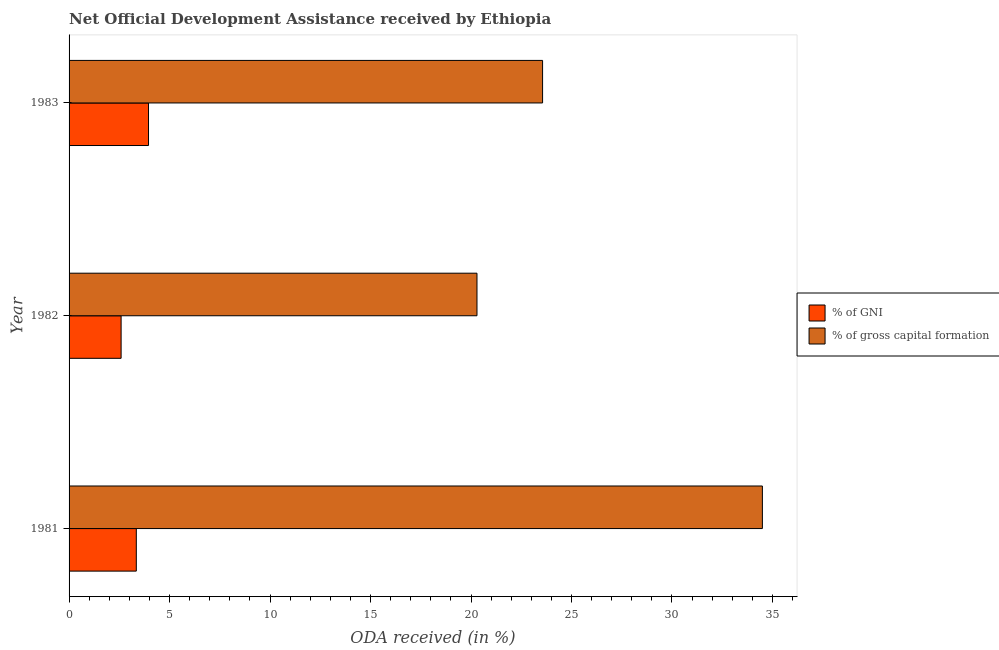How many different coloured bars are there?
Make the answer very short. 2. Are the number of bars per tick equal to the number of legend labels?
Provide a succinct answer. Yes. Are the number of bars on each tick of the Y-axis equal?
Offer a very short reply. Yes. How many bars are there on the 2nd tick from the bottom?
Offer a terse response. 2. In how many cases, is the number of bars for a given year not equal to the number of legend labels?
Make the answer very short. 0. What is the oda received as percentage of gni in 1981?
Offer a terse response. 3.35. Across all years, what is the maximum oda received as percentage of gross capital formation?
Give a very brief answer. 34.5. Across all years, what is the minimum oda received as percentage of gni?
Offer a very short reply. 2.59. In which year was the oda received as percentage of gross capital formation minimum?
Make the answer very short. 1982. What is the total oda received as percentage of gross capital formation in the graph?
Make the answer very short. 78.36. What is the difference between the oda received as percentage of gross capital formation in 1981 and that in 1983?
Your answer should be compact. 10.94. What is the difference between the oda received as percentage of gross capital formation in 1982 and the oda received as percentage of gni in 1983?
Keep it short and to the point. 16.34. What is the average oda received as percentage of gni per year?
Ensure brevity in your answer.  3.3. In the year 1981, what is the difference between the oda received as percentage of gross capital formation and oda received as percentage of gni?
Keep it short and to the point. 31.15. In how many years, is the oda received as percentage of gross capital formation greater than 7 %?
Your answer should be very brief. 3. What is the ratio of the oda received as percentage of gross capital formation in 1981 to that in 1983?
Provide a succinct answer. 1.46. Is the oda received as percentage of gross capital formation in 1982 less than that in 1983?
Provide a short and direct response. Yes. What is the difference between the highest and the second highest oda received as percentage of gross capital formation?
Your answer should be compact. 10.94. What is the difference between the highest and the lowest oda received as percentage of gross capital formation?
Your answer should be very brief. 14.2. In how many years, is the oda received as percentage of gross capital formation greater than the average oda received as percentage of gross capital formation taken over all years?
Give a very brief answer. 1. What does the 1st bar from the top in 1982 represents?
Provide a succinct answer. % of gross capital formation. What does the 2nd bar from the bottom in 1982 represents?
Offer a very short reply. % of gross capital formation. How many bars are there?
Offer a terse response. 6. Are all the bars in the graph horizontal?
Offer a terse response. Yes. Does the graph contain any zero values?
Your response must be concise. No. Where does the legend appear in the graph?
Keep it short and to the point. Center right. How many legend labels are there?
Your answer should be very brief. 2. What is the title of the graph?
Provide a succinct answer. Net Official Development Assistance received by Ethiopia. Does "Stunting" appear as one of the legend labels in the graph?
Give a very brief answer. No. What is the label or title of the X-axis?
Offer a very short reply. ODA received (in %). What is the label or title of the Y-axis?
Ensure brevity in your answer.  Year. What is the ODA received (in %) in % of GNI in 1981?
Offer a very short reply. 3.35. What is the ODA received (in %) of % of gross capital formation in 1981?
Make the answer very short. 34.5. What is the ODA received (in %) of % of GNI in 1982?
Your answer should be very brief. 2.59. What is the ODA received (in %) of % of gross capital formation in 1982?
Offer a very short reply. 20.3. What is the ODA received (in %) of % of GNI in 1983?
Your response must be concise. 3.95. What is the ODA received (in %) of % of gross capital formation in 1983?
Provide a succinct answer. 23.56. Across all years, what is the maximum ODA received (in %) in % of GNI?
Your answer should be compact. 3.95. Across all years, what is the maximum ODA received (in %) of % of gross capital formation?
Provide a succinct answer. 34.5. Across all years, what is the minimum ODA received (in %) of % of GNI?
Your answer should be very brief. 2.59. Across all years, what is the minimum ODA received (in %) in % of gross capital formation?
Your answer should be compact. 20.3. What is the total ODA received (in %) in % of GNI in the graph?
Your answer should be compact. 9.89. What is the total ODA received (in %) of % of gross capital formation in the graph?
Provide a succinct answer. 78.36. What is the difference between the ODA received (in %) in % of GNI in 1981 and that in 1982?
Your answer should be very brief. 0.76. What is the difference between the ODA received (in %) of % of gross capital formation in 1981 and that in 1982?
Offer a terse response. 14.2. What is the difference between the ODA received (in %) in % of GNI in 1981 and that in 1983?
Offer a very short reply. -0.61. What is the difference between the ODA received (in %) of % of gross capital formation in 1981 and that in 1983?
Your answer should be compact. 10.94. What is the difference between the ODA received (in %) in % of GNI in 1982 and that in 1983?
Your response must be concise. -1.36. What is the difference between the ODA received (in %) of % of gross capital formation in 1982 and that in 1983?
Your answer should be compact. -3.26. What is the difference between the ODA received (in %) in % of GNI in 1981 and the ODA received (in %) in % of gross capital formation in 1982?
Provide a succinct answer. -16.95. What is the difference between the ODA received (in %) of % of GNI in 1981 and the ODA received (in %) of % of gross capital formation in 1983?
Ensure brevity in your answer.  -20.22. What is the difference between the ODA received (in %) in % of GNI in 1982 and the ODA received (in %) in % of gross capital formation in 1983?
Your response must be concise. -20.97. What is the average ODA received (in %) in % of GNI per year?
Your answer should be very brief. 3.3. What is the average ODA received (in %) of % of gross capital formation per year?
Your answer should be very brief. 26.12. In the year 1981, what is the difference between the ODA received (in %) in % of GNI and ODA received (in %) in % of gross capital formation?
Provide a succinct answer. -31.15. In the year 1982, what is the difference between the ODA received (in %) of % of GNI and ODA received (in %) of % of gross capital formation?
Provide a succinct answer. -17.71. In the year 1983, what is the difference between the ODA received (in %) in % of GNI and ODA received (in %) in % of gross capital formation?
Ensure brevity in your answer.  -19.61. What is the ratio of the ODA received (in %) in % of GNI in 1981 to that in 1982?
Give a very brief answer. 1.29. What is the ratio of the ODA received (in %) in % of gross capital formation in 1981 to that in 1982?
Keep it short and to the point. 1.7. What is the ratio of the ODA received (in %) of % of GNI in 1981 to that in 1983?
Offer a very short reply. 0.85. What is the ratio of the ODA received (in %) in % of gross capital formation in 1981 to that in 1983?
Ensure brevity in your answer.  1.46. What is the ratio of the ODA received (in %) in % of GNI in 1982 to that in 1983?
Your response must be concise. 0.66. What is the ratio of the ODA received (in %) in % of gross capital formation in 1982 to that in 1983?
Your response must be concise. 0.86. What is the difference between the highest and the second highest ODA received (in %) in % of GNI?
Offer a terse response. 0.61. What is the difference between the highest and the second highest ODA received (in %) of % of gross capital formation?
Offer a terse response. 10.94. What is the difference between the highest and the lowest ODA received (in %) of % of GNI?
Your answer should be very brief. 1.36. What is the difference between the highest and the lowest ODA received (in %) in % of gross capital formation?
Make the answer very short. 14.2. 